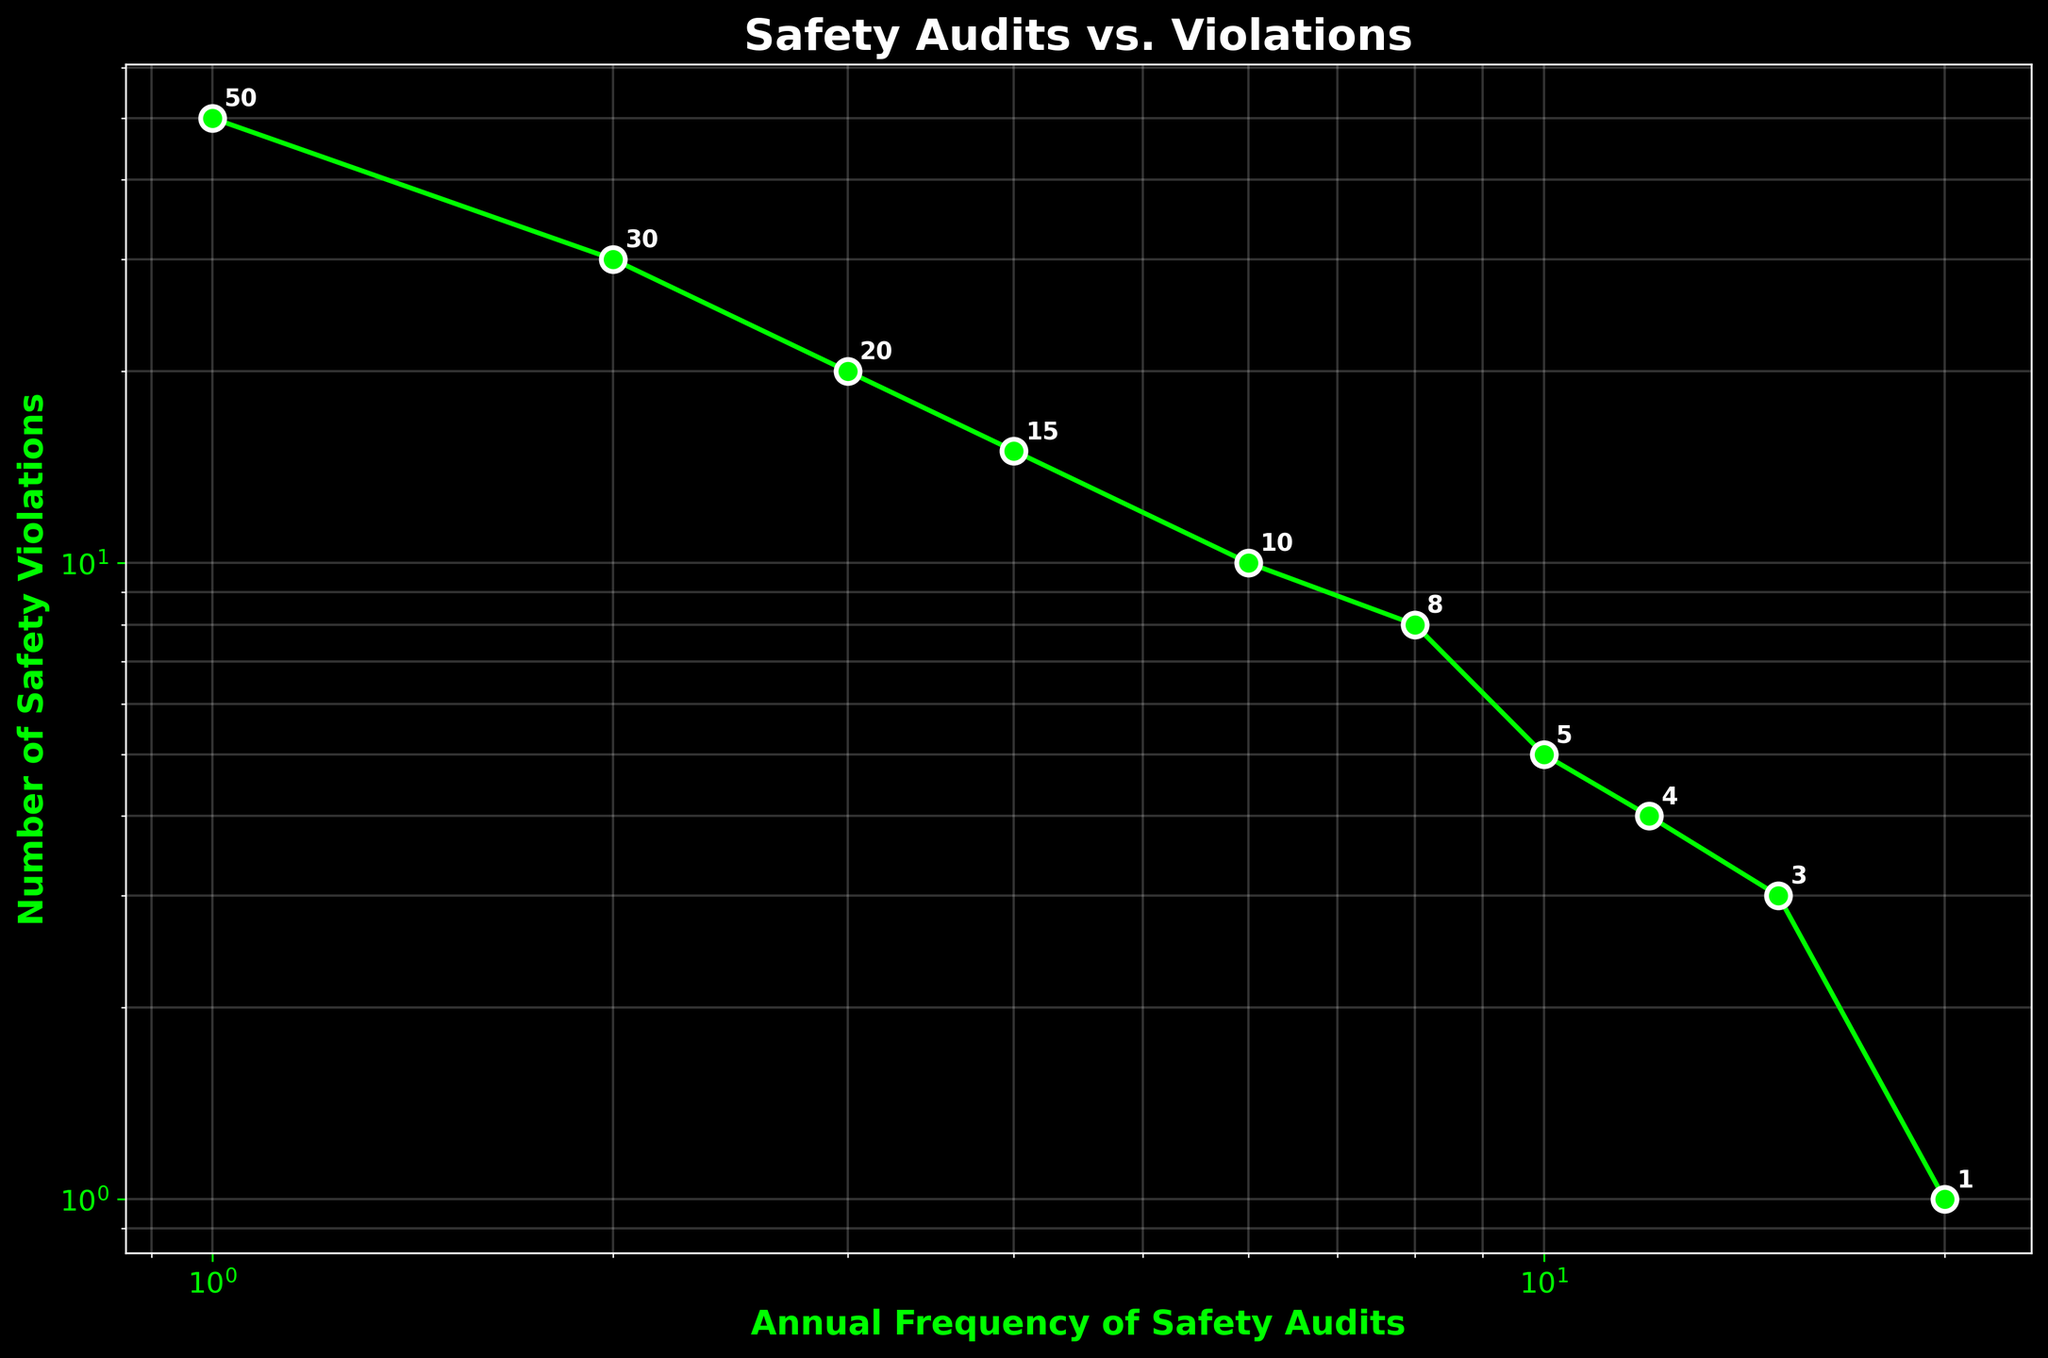What is the title of the plot? The title of the plot is displayed at the top center of the figure.
Answer: Safety Audits vs. Violations What variables are represented on the x and y axes? The x-axis is labeled "Annual Frequency of Safety Audits," and the y-axis is labeled "Number of Safety Violations."
Answer: Annual Frequency of Safety Audits, Number of Safety Violations How many data points are plotted on the figure? Each data point on the figure corresponds to a pair of values (one from the x-axis and one from the y-axis). Counting all such pairs gives us the number of data points.
Answer: 10 What is the color of the line connecting the data points? The line connecting the data points is visually inspected on the figure.
Answer: Green Between which two annual frequencies of safety audits is the drop in the number of safety violations the largest? To find the largest drop, compare the differences in the y-values (number of safety violations) between consecutive x-values (annual frequency of safety audits).
Answer: From 1 to 2 audits What is the approximate number of safety violations when the annual frequency of safety audits is 10? Locate the x-axis value of 10 and then refer to the corresponding y-axis value.
Answer: 5 How does the number of safety violations change as the annual frequency of safety audits increases? Observe the general trend of the data points as the x-axis values (annual frequency) increase.
Answer: Decreases What is the ratio of the number of safety violations when the annual frequency of audits is 1 compared to when it is 20? Find the y-values for x = 1 and x = 20 and compute the ratio. The values are 50 and 1, respectively, so the ratio is 50 to 1.
Answer: 50:1 At how many data points do the annotations match the actual data values? Annotations near the data points are exact values - count how many are shown in the plot.
Answer: 10 If you increase the annual frequency of safety audits from 4 to 8, by how many violations does the number of safety violations decrease? Identify the y-values at 4 and 8 audits from the plot, then compute the difference. The y-values are 15 and 8, respectively, so the difference is 15 - 8 = 7.
Answer: 7 If the trend continues, what might be the expected number of safety violations if the annual frequency of safety audits reaches 25? Extrapolate based on the observed trend. As the x-axis values increase, the y-axis value continues to decrease. Since the decrease is sharp, the number of violations may approach zero.
Answer: Close to 0 